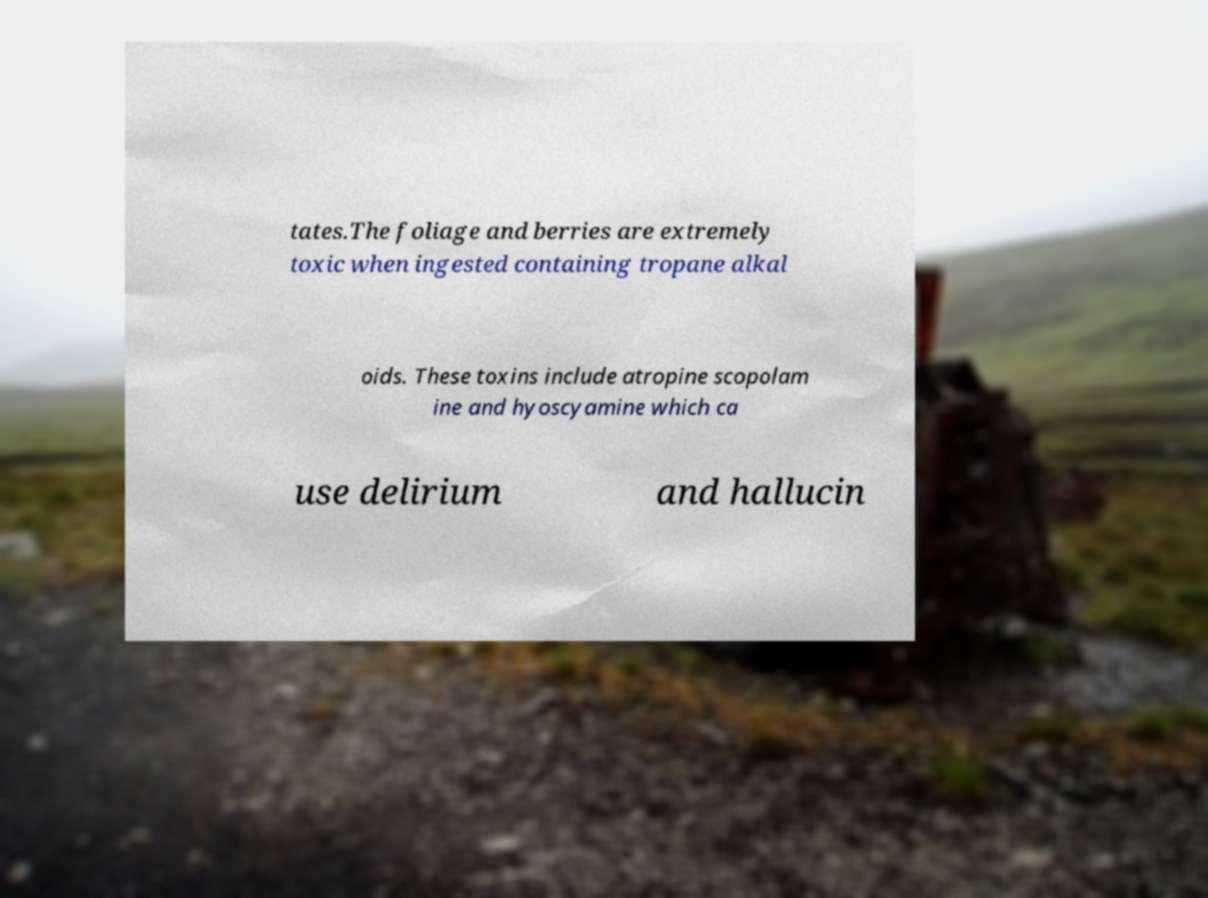Please read and relay the text visible in this image. What does it say? tates.The foliage and berries are extremely toxic when ingested containing tropane alkal oids. These toxins include atropine scopolam ine and hyoscyamine which ca use delirium and hallucin 